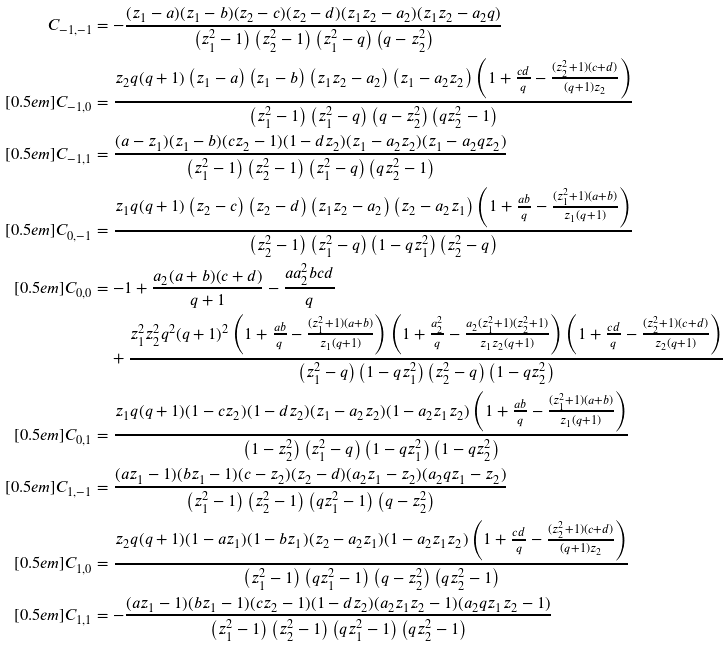Convert formula to latex. <formula><loc_0><loc_0><loc_500><loc_500>C _ { - 1 , - 1 } & = - \frac { ( z _ { 1 } - a ) ( z _ { 1 } - b ) ( z _ { 2 } - c ) ( z _ { 2 } - d ) ( z _ { 1 } z _ { 2 } - a _ { 2 } ) ( z _ { 1 } z _ { 2 } - a _ { 2 } q ) } { \left ( z _ { 1 } ^ { 2 } - 1 \right ) \left ( z _ { 2 } ^ { 2 } - 1 \right ) \left ( z _ { 1 } ^ { 2 } - q \right ) \left ( q - z _ { 2 } ^ { 2 } \right ) } \\ [ 0 . 5 e m ] C _ { - 1 , 0 } & = \frac { z _ { 2 } q ( q + 1 ) \left ( z _ { 1 } - a \right ) \left ( z _ { 1 } - b \right ) \left ( z _ { 1 } z _ { 2 } - a _ { 2 } \right ) \left ( z _ { 1 } - a _ { 2 } z _ { 2 } \right ) \left ( 1 + \frac { c d } { q } - \frac { ( z _ { 2 } ^ { 2 } + 1 ) ( c + d ) } { ( q + 1 ) z _ { 2 } } \right ) } { \left ( z _ { 1 } ^ { 2 } - 1 \right ) \left ( z _ { 1 } ^ { 2 } - q \right ) \left ( q - z _ { 2 } ^ { 2 } \right ) \left ( q z _ { 2 } ^ { 2 } - 1 \right ) } \\ [ 0 . 5 e m ] C _ { - 1 , 1 } & = \frac { ( a - z _ { 1 } ) ( z _ { 1 } - b ) ( c z _ { 2 } - 1 ) ( 1 - d z _ { 2 } ) ( z _ { 1 } - a _ { 2 } z _ { 2 } ) ( z _ { 1 } - a _ { 2 } q z _ { 2 } ) } { \left ( z _ { 1 } ^ { 2 } - 1 \right ) \left ( z _ { 2 } ^ { 2 } - 1 \right ) \left ( z _ { 1 } ^ { 2 } - q \right ) \left ( q z _ { 2 } ^ { 2 } - 1 \right ) } \\ [ 0 . 5 e m ] C _ { 0 , - 1 } & = \frac { z _ { 1 } q ( q + 1 ) \left ( z _ { 2 } - c \right ) \left ( z _ { 2 } - d \right ) \left ( z _ { 1 } z _ { 2 } - a _ { 2 } \right ) \left ( z _ { 2 } - a _ { 2 } z _ { 1 } \right ) \left ( 1 + \frac { a b } { q } - \frac { ( z _ { 1 } ^ { 2 } + 1 ) ( a + b ) } { z _ { 1 } ( q + 1 ) } \right ) } { \left ( z _ { 2 } ^ { 2 } - 1 \right ) \left ( z _ { 1 } ^ { 2 } - q \right ) \left ( 1 - q z _ { 1 } ^ { 2 } \right ) \left ( z _ { 2 } ^ { 2 } - q \right ) } \\ [ 0 . 5 e m ] C _ { 0 , 0 } & = - 1 + \frac { a _ { 2 } ( a + b ) ( c + d ) } { q + 1 } - \frac { a a _ { 2 } ^ { 2 } b c d } { q } \\ & \quad + \frac { z _ { 1 } ^ { 2 } z _ { 2 } ^ { 2 } q ^ { 2 } ( q + 1 ) ^ { 2 } \left ( 1 + \frac { a b } { q } - \frac { ( z _ { 1 } ^ { 2 } + 1 ) ( a + b ) } { z _ { 1 } ( q + 1 ) } \right ) \left ( 1 + \frac { a _ { 2 } ^ { 2 } } { q } - \frac { a _ { 2 } ( z _ { 1 } ^ { 2 } + 1 ) ( z _ { 2 } ^ { 2 } + 1 ) } { z _ { 1 } z _ { 2 } ( q + 1 ) } \right ) \left ( 1 + \frac { c d } { q } - \frac { ( z _ { 2 } ^ { 2 } + 1 ) ( c + d ) } { z _ { 2 } ( q + 1 ) } \right ) } { \left ( z _ { 1 } ^ { 2 } - q \right ) \left ( 1 - q z _ { 1 } ^ { 2 } \right ) \left ( z _ { 2 } ^ { 2 } - q \right ) \left ( 1 - q z _ { 2 } ^ { 2 } \right ) } \\ [ 0 . 5 e m ] C _ { 0 , 1 } & = \frac { z _ { 1 } q ( q + 1 ) ( 1 - c z _ { 2 } ) ( 1 - d z _ { 2 } ) ( z _ { 1 } - a _ { 2 } z _ { 2 } ) ( 1 - a _ { 2 } z _ { 1 } z _ { 2 } ) \left ( 1 + \frac { a b } { q } - \frac { ( z _ { 1 } ^ { 2 } + 1 ) ( a + b ) } { z _ { 1 } ( q + 1 ) } \right ) } { \left ( 1 - z _ { 2 } ^ { 2 } \right ) \left ( z _ { 1 } ^ { 2 } - q \right ) \left ( 1 - q z _ { 1 } ^ { 2 } \right ) \left ( 1 - q z _ { 2 } ^ { 2 } \right ) } \\ [ 0 . 5 e m ] C _ { 1 , - 1 } & = \frac { ( a z _ { 1 } - 1 ) ( b z _ { 1 } - 1 ) ( c - z _ { 2 } ) ( z _ { 2 } - d ) ( a _ { 2 } z _ { 1 } - z _ { 2 } ) ( a _ { 2 } q z _ { 1 } - z _ { 2 } ) } { \left ( z _ { 1 } ^ { 2 } - 1 \right ) \left ( z _ { 2 } ^ { 2 } - 1 \right ) \left ( q z _ { 1 } ^ { 2 } - 1 \right ) \left ( q - z _ { 2 } ^ { 2 } \right ) } \\ [ 0 . 5 e m ] C _ { 1 , 0 } & = \frac { z _ { 2 } q ( q + 1 ) ( 1 - a z _ { 1 } ) ( 1 - b z _ { 1 } ) ( z _ { 2 } - a _ { 2 } z _ { 1 } ) ( 1 - a _ { 2 } z _ { 1 } z _ { 2 } ) \left ( 1 + \frac { c d } { q } - \frac { ( z _ { 2 } ^ { 2 } + 1 ) ( c + d ) } { ( q + 1 ) z _ { 2 } } \right ) } { \left ( z _ { 1 } ^ { 2 } - 1 \right ) \left ( q z _ { 1 } ^ { 2 } - 1 \right ) \left ( q - z _ { 2 } ^ { 2 } \right ) \left ( q z _ { 2 } ^ { 2 } - 1 \right ) } \\ [ 0 . 5 e m ] C _ { 1 , 1 } & = - \frac { ( a z _ { 1 } - 1 ) ( b z _ { 1 } - 1 ) ( c z _ { 2 } - 1 ) ( 1 - d z _ { 2 } ) ( a _ { 2 } z _ { 1 } z _ { 2 } - 1 ) ( a _ { 2 } q z _ { 1 } z _ { 2 } - 1 ) } { \left ( z _ { 1 } ^ { 2 } - 1 \right ) \left ( z _ { 2 } ^ { 2 } - 1 \right ) \left ( q z _ { 1 } ^ { 2 } - 1 \right ) \left ( q z _ { 2 } ^ { 2 } - 1 \right ) }</formula> 